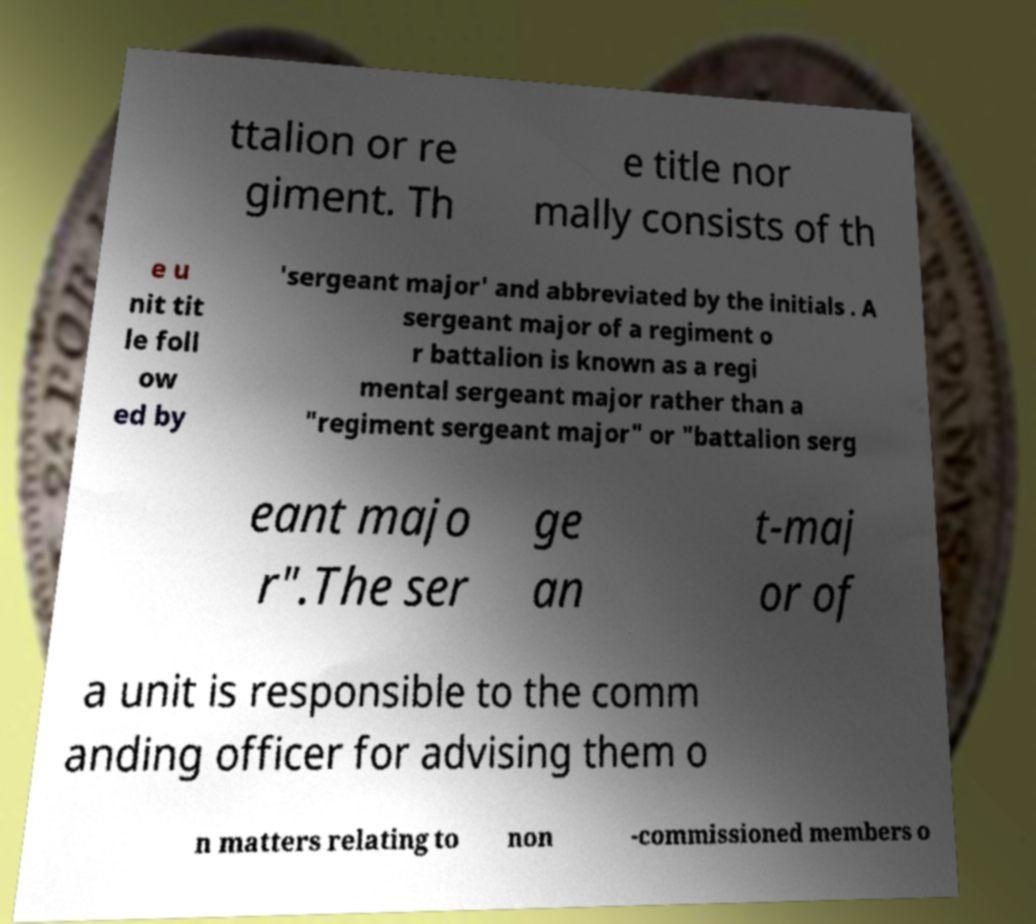Please identify and transcribe the text found in this image. ttalion or re giment. Th e title nor mally consists of th e u nit tit le foll ow ed by 'sergeant major' and abbreviated by the initials . A sergeant major of a regiment o r battalion is known as a regi mental sergeant major rather than a "regiment sergeant major" or "battalion serg eant majo r".The ser ge an t-maj or of a unit is responsible to the comm anding officer for advising them o n matters relating to non -commissioned members o 